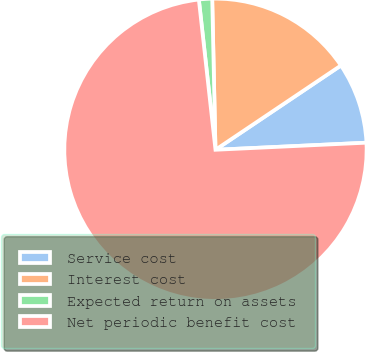Convert chart to OTSL. <chart><loc_0><loc_0><loc_500><loc_500><pie_chart><fcel>Service cost<fcel>Interest cost<fcel>Expected return on assets<fcel>Net periodic benefit cost<nl><fcel>8.67%<fcel>15.93%<fcel>1.41%<fcel>73.99%<nl></chart> 